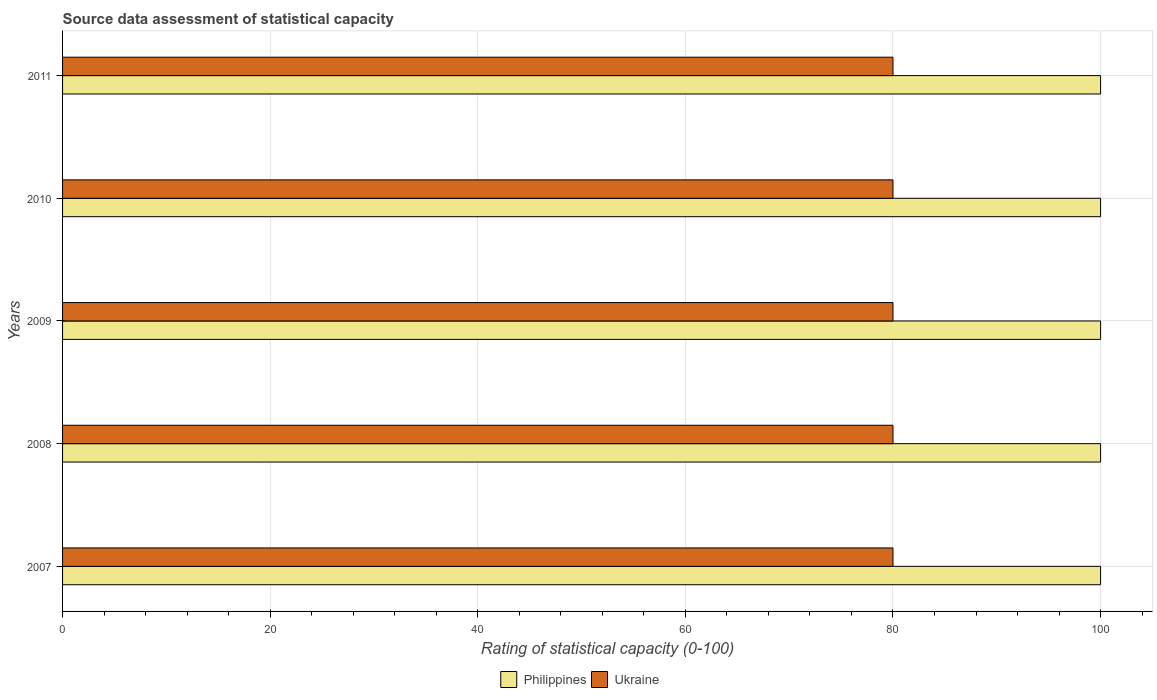How many different coloured bars are there?
Make the answer very short. 2. How many groups of bars are there?
Your response must be concise. 5. Are the number of bars per tick equal to the number of legend labels?
Provide a short and direct response. Yes. How many bars are there on the 5th tick from the top?
Make the answer very short. 2. How many bars are there on the 1st tick from the bottom?
Your answer should be very brief. 2. What is the label of the 1st group of bars from the top?
Provide a short and direct response. 2011. What is the rating of statistical capacity in Ukraine in 2009?
Ensure brevity in your answer.  80. Across all years, what is the maximum rating of statistical capacity in Philippines?
Your answer should be very brief. 100. Across all years, what is the minimum rating of statistical capacity in Ukraine?
Your answer should be very brief. 80. In which year was the rating of statistical capacity in Philippines maximum?
Offer a very short reply. 2007. What is the total rating of statistical capacity in Philippines in the graph?
Your response must be concise. 500. What is the difference between the rating of statistical capacity in Ukraine in 2009 and that in 2010?
Ensure brevity in your answer.  0. What is the difference between the rating of statistical capacity in Philippines in 2010 and the rating of statistical capacity in Ukraine in 2007?
Give a very brief answer. 20. In the year 2011, what is the difference between the rating of statistical capacity in Philippines and rating of statistical capacity in Ukraine?
Offer a very short reply. 20. What is the ratio of the rating of statistical capacity in Ukraine in 2010 to that in 2011?
Make the answer very short. 1. Is the difference between the rating of statistical capacity in Philippines in 2008 and 2010 greater than the difference between the rating of statistical capacity in Ukraine in 2008 and 2010?
Provide a succinct answer. No. What is the difference between the highest and the second highest rating of statistical capacity in Philippines?
Ensure brevity in your answer.  0. What does the 1st bar from the top in 2011 represents?
Give a very brief answer. Ukraine. What does the 2nd bar from the bottom in 2010 represents?
Keep it short and to the point. Ukraine. How many years are there in the graph?
Provide a short and direct response. 5. What is the difference between two consecutive major ticks on the X-axis?
Give a very brief answer. 20. Does the graph contain any zero values?
Make the answer very short. No. Does the graph contain grids?
Provide a short and direct response. Yes. How many legend labels are there?
Provide a succinct answer. 2. What is the title of the graph?
Make the answer very short. Source data assessment of statistical capacity. What is the label or title of the X-axis?
Your response must be concise. Rating of statistical capacity (0-100). What is the Rating of statistical capacity (0-100) in Ukraine in 2007?
Keep it short and to the point. 80. What is the Rating of statistical capacity (0-100) of Philippines in 2008?
Your answer should be very brief. 100. What is the Rating of statistical capacity (0-100) in Ukraine in 2008?
Your answer should be very brief. 80. What is the Rating of statistical capacity (0-100) in Philippines in 2009?
Give a very brief answer. 100. What is the Rating of statistical capacity (0-100) of Philippines in 2011?
Make the answer very short. 100. Across all years, what is the maximum Rating of statistical capacity (0-100) in Ukraine?
Offer a terse response. 80. Across all years, what is the minimum Rating of statistical capacity (0-100) in Philippines?
Give a very brief answer. 100. What is the total Rating of statistical capacity (0-100) in Philippines in the graph?
Ensure brevity in your answer.  500. What is the difference between the Rating of statistical capacity (0-100) of Philippines in 2007 and that in 2008?
Provide a short and direct response. 0. What is the difference between the Rating of statistical capacity (0-100) of Philippines in 2007 and that in 2010?
Your answer should be very brief. 0. What is the difference between the Rating of statistical capacity (0-100) of Philippines in 2008 and that in 2009?
Provide a succinct answer. 0. What is the difference between the Rating of statistical capacity (0-100) of Ukraine in 2008 and that in 2009?
Give a very brief answer. 0. What is the difference between the Rating of statistical capacity (0-100) of Philippines in 2008 and that in 2010?
Offer a terse response. 0. What is the difference between the Rating of statistical capacity (0-100) of Philippines in 2009 and that in 2010?
Provide a short and direct response. 0. What is the difference between the Rating of statistical capacity (0-100) in Philippines in 2009 and that in 2011?
Your response must be concise. 0. What is the difference between the Rating of statistical capacity (0-100) in Ukraine in 2009 and that in 2011?
Make the answer very short. 0. What is the difference between the Rating of statistical capacity (0-100) of Philippines in 2007 and the Rating of statistical capacity (0-100) of Ukraine in 2008?
Your answer should be very brief. 20. What is the difference between the Rating of statistical capacity (0-100) of Philippines in 2007 and the Rating of statistical capacity (0-100) of Ukraine in 2009?
Offer a terse response. 20. What is the difference between the Rating of statistical capacity (0-100) in Philippines in 2007 and the Rating of statistical capacity (0-100) in Ukraine in 2010?
Provide a short and direct response. 20. What is the difference between the Rating of statistical capacity (0-100) in Philippines in 2008 and the Rating of statistical capacity (0-100) in Ukraine in 2011?
Offer a terse response. 20. What is the difference between the Rating of statistical capacity (0-100) of Philippines in 2009 and the Rating of statistical capacity (0-100) of Ukraine in 2010?
Your answer should be compact. 20. What is the average Rating of statistical capacity (0-100) in Ukraine per year?
Provide a short and direct response. 80. In the year 2007, what is the difference between the Rating of statistical capacity (0-100) in Philippines and Rating of statistical capacity (0-100) in Ukraine?
Offer a terse response. 20. In the year 2010, what is the difference between the Rating of statistical capacity (0-100) of Philippines and Rating of statistical capacity (0-100) of Ukraine?
Provide a short and direct response. 20. What is the ratio of the Rating of statistical capacity (0-100) in Philippines in 2007 to that in 2009?
Provide a short and direct response. 1. What is the ratio of the Rating of statistical capacity (0-100) of Ukraine in 2007 to that in 2009?
Your response must be concise. 1. What is the ratio of the Rating of statistical capacity (0-100) in Philippines in 2007 to that in 2010?
Keep it short and to the point. 1. What is the ratio of the Rating of statistical capacity (0-100) in Ukraine in 2007 to that in 2010?
Your response must be concise. 1. What is the ratio of the Rating of statistical capacity (0-100) in Philippines in 2007 to that in 2011?
Provide a short and direct response. 1. What is the ratio of the Rating of statistical capacity (0-100) of Ukraine in 2007 to that in 2011?
Your answer should be very brief. 1. What is the ratio of the Rating of statistical capacity (0-100) in Philippines in 2008 to that in 2010?
Provide a succinct answer. 1. What is the ratio of the Rating of statistical capacity (0-100) in Ukraine in 2008 to that in 2011?
Your answer should be very brief. 1. What is the ratio of the Rating of statistical capacity (0-100) of Philippines in 2009 to that in 2010?
Provide a short and direct response. 1. What is the ratio of the Rating of statistical capacity (0-100) of Ukraine in 2009 to that in 2010?
Ensure brevity in your answer.  1. What is the ratio of the Rating of statistical capacity (0-100) of Philippines in 2010 to that in 2011?
Your answer should be very brief. 1. What is the difference between the highest and the second highest Rating of statistical capacity (0-100) of Philippines?
Keep it short and to the point. 0. What is the difference between the highest and the second highest Rating of statistical capacity (0-100) in Ukraine?
Your response must be concise. 0. What is the difference between the highest and the lowest Rating of statistical capacity (0-100) of Philippines?
Keep it short and to the point. 0. 